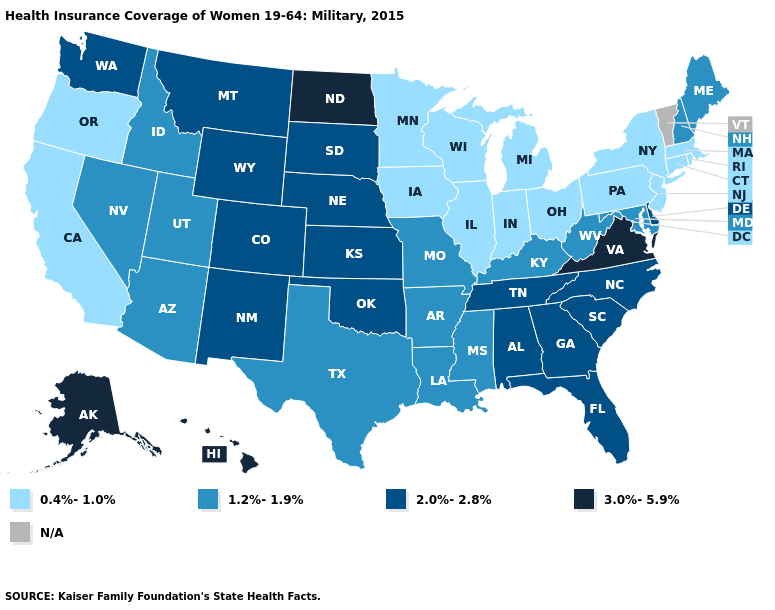Name the states that have a value in the range 3.0%-5.9%?
Give a very brief answer. Alaska, Hawaii, North Dakota, Virginia. Among the states that border Oklahoma , does Arkansas have the lowest value?
Quick response, please. Yes. What is the lowest value in the Northeast?
Be succinct. 0.4%-1.0%. What is the value of Nebraska?
Keep it brief. 2.0%-2.8%. Name the states that have a value in the range 0.4%-1.0%?
Be succinct. California, Connecticut, Illinois, Indiana, Iowa, Massachusetts, Michigan, Minnesota, New Jersey, New York, Ohio, Oregon, Pennsylvania, Rhode Island, Wisconsin. Name the states that have a value in the range 3.0%-5.9%?
Answer briefly. Alaska, Hawaii, North Dakota, Virginia. What is the lowest value in states that border South Dakota?
Be succinct. 0.4%-1.0%. What is the value of Vermont?
Be succinct. N/A. What is the value of Oregon?
Keep it brief. 0.4%-1.0%. What is the value of South Dakota?
Concise answer only. 2.0%-2.8%. What is the value of Iowa?
Quick response, please. 0.4%-1.0%. Among the states that border Illinois , does Wisconsin have the highest value?
Concise answer only. No. What is the value of West Virginia?
Answer briefly. 1.2%-1.9%. 